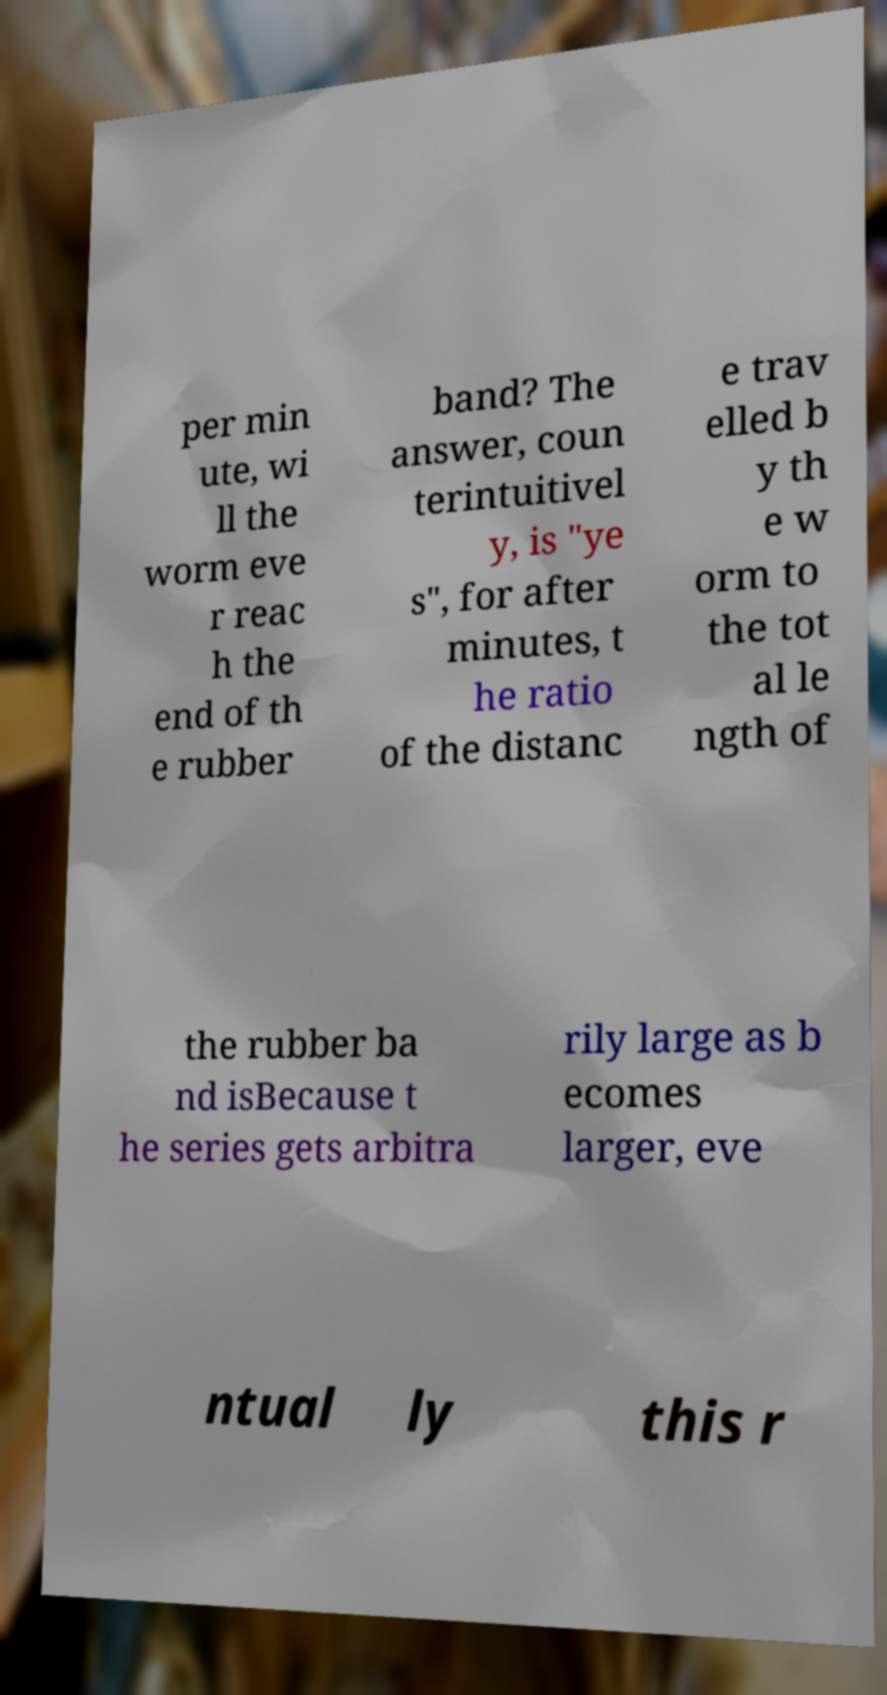I need the written content from this picture converted into text. Can you do that? per min ute, wi ll the worm eve r reac h the end of th e rubber band? The answer, coun terintuitivel y, is "ye s", for after minutes, t he ratio of the distanc e trav elled b y th e w orm to the tot al le ngth of the rubber ba nd isBecause t he series gets arbitra rily large as b ecomes larger, eve ntual ly this r 